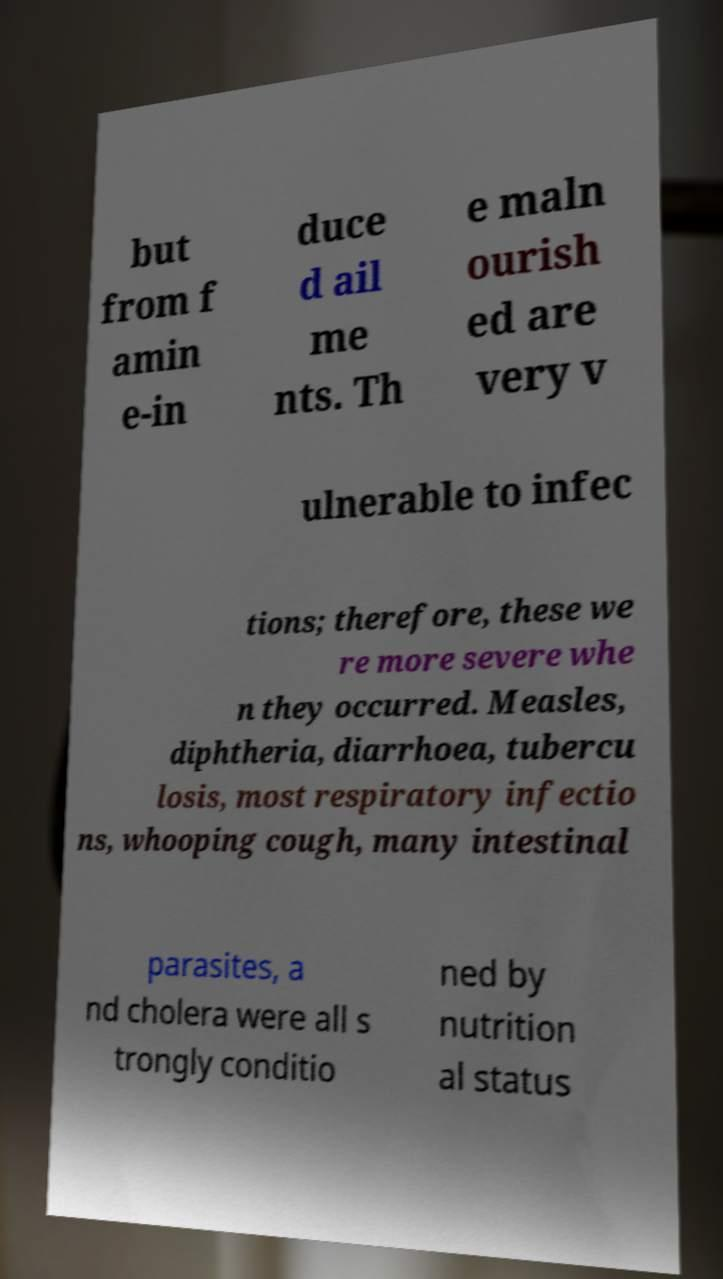Can you accurately transcribe the text from the provided image for me? but from f amin e-in duce d ail me nts. Th e maln ourish ed are very v ulnerable to infec tions; therefore, these we re more severe whe n they occurred. Measles, diphtheria, diarrhoea, tubercu losis, most respiratory infectio ns, whooping cough, many intestinal parasites, a nd cholera were all s trongly conditio ned by nutrition al status 